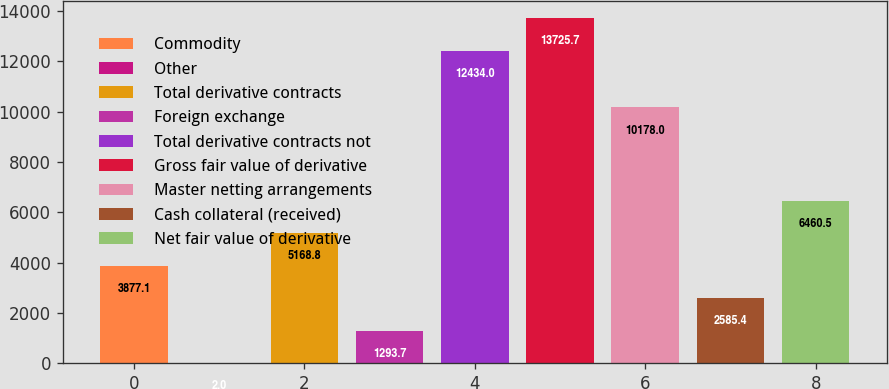Convert chart. <chart><loc_0><loc_0><loc_500><loc_500><bar_chart><fcel>Commodity<fcel>Other<fcel>Total derivative contracts<fcel>Foreign exchange<fcel>Total derivative contracts not<fcel>Gross fair value of derivative<fcel>Master netting arrangements<fcel>Cash collateral (received)<fcel>Net fair value of derivative<nl><fcel>3877.1<fcel>2<fcel>5168.8<fcel>1293.7<fcel>12434<fcel>13725.7<fcel>10178<fcel>2585.4<fcel>6460.5<nl></chart> 